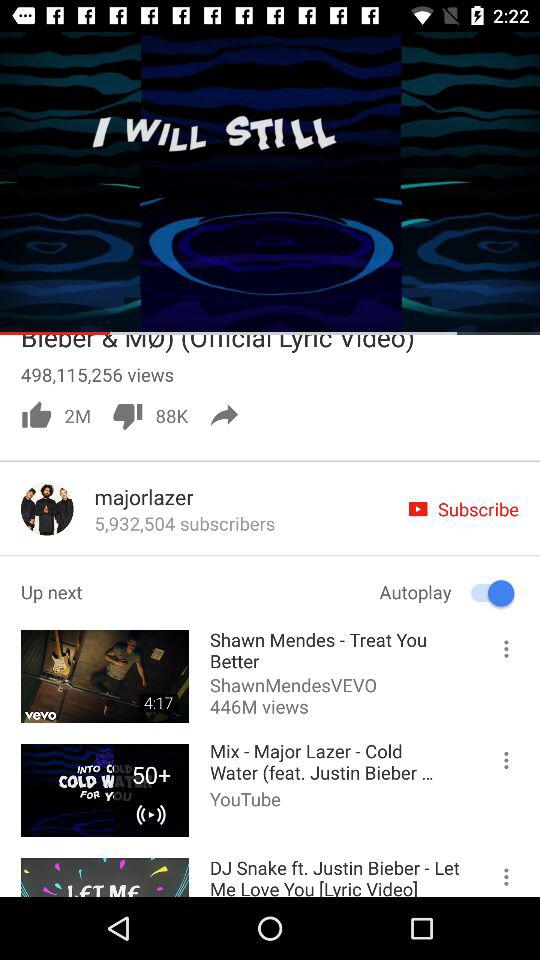How many subscribers of "Coldplay Official" are there? There are 7,876,525 subscribers of "Coldplay Official". 